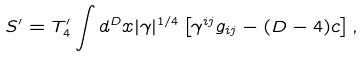Convert formula to latex. <formula><loc_0><loc_0><loc_500><loc_500>S ^ { \prime } = T ^ { \prime } _ { 4 } \int d ^ { D } x | \gamma | ^ { 1 / 4 } \left [ \gamma ^ { i j } g _ { i j } - ( D - 4 ) c \right ] ,</formula> 